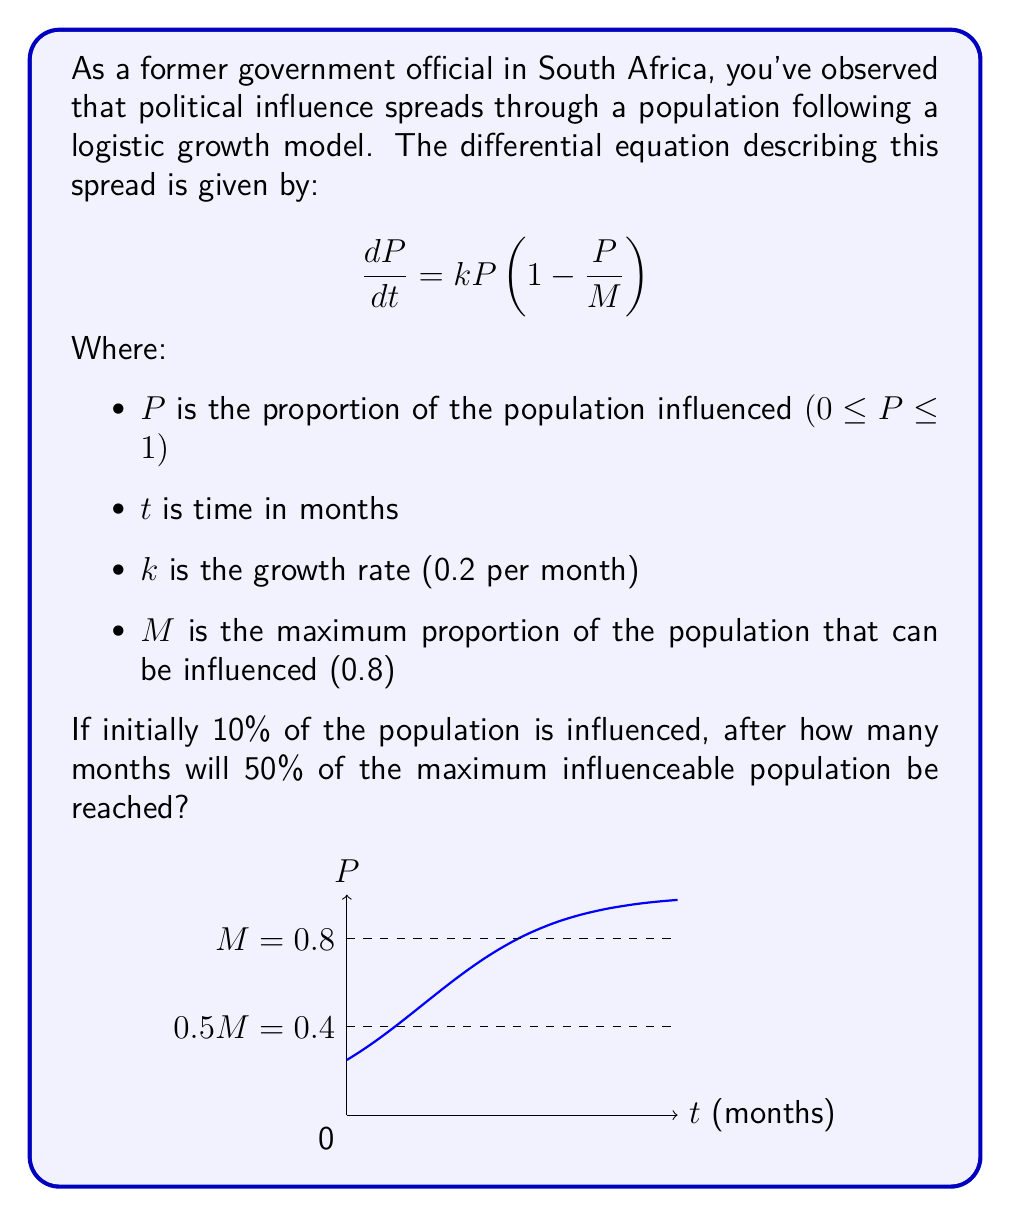Could you help me with this problem? Let's approach this step-by-step:

1) First, we need to solve the logistic differential equation. The solution to this equation is:

   $$P(t) = \frac{M}{1 + (\frac{M}{P_0} - 1)e^{-kt}}$$

   Where $P_0$ is the initial proportion of the population influenced.

2) We're given:
   - $k = 0.2$ per month
   - $M = 0.8$
   - $P_0 = 0.1$ (10% initial influence)

3) We want to find $t$ when $P(t) = 0.5M = 0.5(0.8) = 0.4$

4) Let's substitute these values into the equation:

   $$0.4 = \frac{0.8}{1 + (\frac{0.8}{0.1} - 1)e^{-0.2t}}$$

5) Simplify:
   $$0.4 = \frac{0.8}{1 + 7e^{-0.2t}}$$

6) Multiply both sides by the denominator:
   $$0.4(1 + 7e^{-0.2t}) = 0.8$$

7) Expand:
   $$0.4 + 2.8e^{-0.2t} = 0.8$$

8) Subtract 0.4 from both sides:
   $$2.8e^{-0.2t} = 0.4$$

9) Divide both sides by 2.8:
   $$e^{-0.2t} = \frac{1}{7}$$

10) Take the natural log of both sides:
    $$-0.2t = \ln(\frac{1}{7})$$

11) Divide both sides by -0.2:
    $$t = -\frac{\ln(\frac{1}{7})}{0.2} = \frac{\ln(7)}{0.2} \approx 9.73$$

Therefore, it will take approximately 9.73 months.
Answer: 9.73 months 